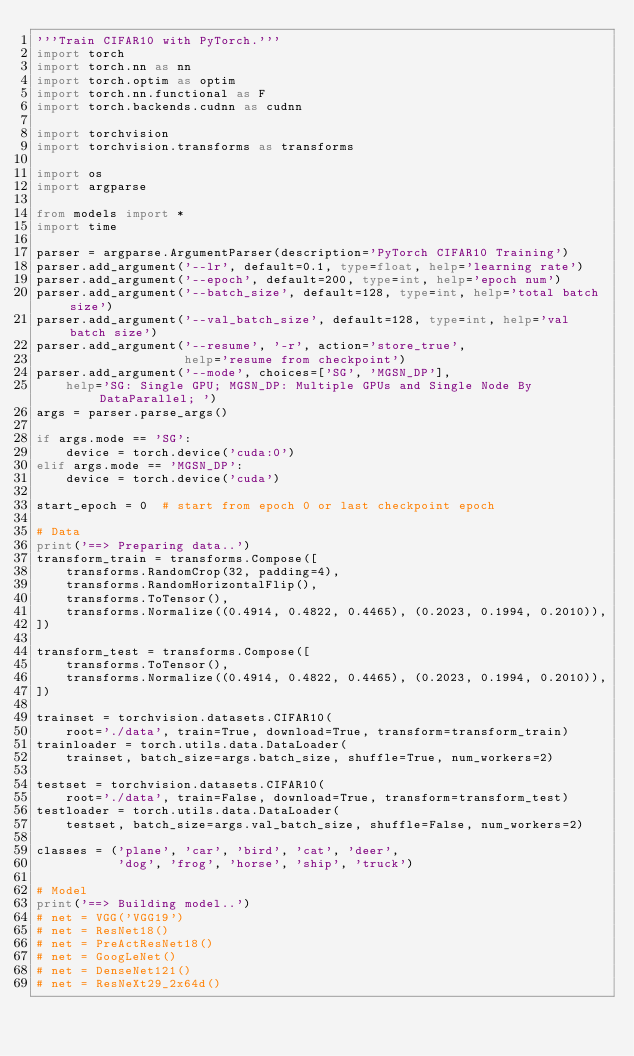<code> <loc_0><loc_0><loc_500><loc_500><_Python_>'''Train CIFAR10 with PyTorch.'''
import torch
import torch.nn as nn
import torch.optim as optim
import torch.nn.functional as F
import torch.backends.cudnn as cudnn

import torchvision
import torchvision.transforms as transforms

import os
import argparse

from models import *
import time

parser = argparse.ArgumentParser(description='PyTorch CIFAR10 Training')
parser.add_argument('--lr', default=0.1, type=float, help='learning rate')
parser.add_argument('--epoch', default=200, type=int, help='epoch num')
parser.add_argument('--batch_size', default=128, type=int, help='total batch size')
parser.add_argument('--val_batch_size', default=128, type=int, help='val batch size')
parser.add_argument('--resume', '-r', action='store_true',
                    help='resume from checkpoint')
parser.add_argument('--mode', choices=['SG', 'MGSN_DP'], 
    help='SG: Single GPU; MGSN_DP: Multiple GPUs and Single Node By DataParallel; ')
args = parser.parse_args()

if args.mode == 'SG':
    device = torch.device('cuda:0')
elif args.mode == 'MGSN_DP':
    device = torch.device('cuda')

start_epoch = 0  # start from epoch 0 or last checkpoint epoch

# Data
print('==> Preparing data..')
transform_train = transforms.Compose([
    transforms.RandomCrop(32, padding=4),
    transforms.RandomHorizontalFlip(),
    transforms.ToTensor(),
    transforms.Normalize((0.4914, 0.4822, 0.4465), (0.2023, 0.1994, 0.2010)),
])

transform_test = transforms.Compose([
    transforms.ToTensor(),
    transforms.Normalize((0.4914, 0.4822, 0.4465), (0.2023, 0.1994, 0.2010)),
])

trainset = torchvision.datasets.CIFAR10(
    root='./data', train=True, download=True, transform=transform_train)
trainloader = torch.utils.data.DataLoader(
    trainset, batch_size=args.batch_size, shuffle=True, num_workers=2)

testset = torchvision.datasets.CIFAR10(
    root='./data', train=False, download=True, transform=transform_test)
testloader = torch.utils.data.DataLoader(
    testset, batch_size=args.val_batch_size, shuffle=False, num_workers=2)

classes = ('plane', 'car', 'bird', 'cat', 'deer',
           'dog', 'frog', 'horse', 'ship', 'truck')

# Model
print('==> Building model..')
# net = VGG('VGG19')
# net = ResNet18()
# net = PreActResNet18()
# net = GoogLeNet()
# net = DenseNet121()
# net = ResNeXt29_2x64d()</code> 